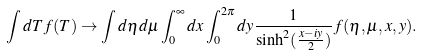Convert formula to latex. <formula><loc_0><loc_0><loc_500><loc_500>\int d T f ( T ) \to \int d \eta d \mu \int _ { 0 } ^ { \infty } d x \int _ { 0 } ^ { 2 \pi } d y \frac { 1 } { \sinh ^ { 2 } ( \frac { x - i y } { 2 } ) } f ( \eta , \mu , x , y ) .</formula> 